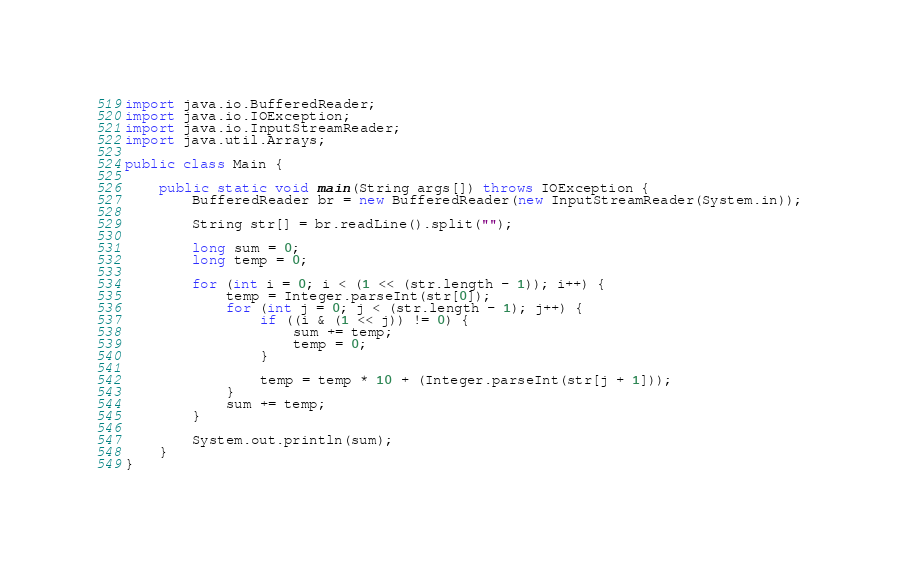<code> <loc_0><loc_0><loc_500><loc_500><_Java_>import java.io.BufferedReader;
import java.io.IOException;
import java.io.InputStreamReader;
import java.util.Arrays;

public class Main {

	public static void main(String args[]) throws IOException {
		BufferedReader br = new BufferedReader(new InputStreamReader(System.in));

		String str[] = br.readLine().split("");

		long sum = 0;
		long temp = 0;

		for (int i = 0; i < (1 << (str.length - 1)); i++) {
			temp = Integer.parseInt(str[0]);
			for (int j = 0; j < (str.length - 1); j++) {
				if ((i & (1 << j)) != 0) {
					sum += temp;
					temp = 0;
				}

				temp = temp * 10 + (Integer.parseInt(str[j + 1]));
			}
			sum += temp;
		}

		System.out.println(sum);
	}
}
</code> 